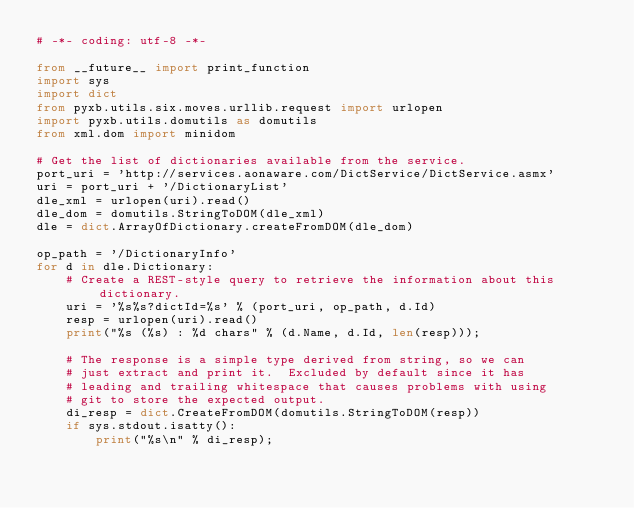<code> <loc_0><loc_0><loc_500><loc_500><_Python_># -*- coding: utf-8 -*-

from __future__ import print_function
import sys
import dict
from pyxb.utils.six.moves.urllib.request import urlopen
import pyxb.utils.domutils as domutils
from xml.dom import minidom

# Get the list of dictionaries available from the service.
port_uri = 'http://services.aonaware.com/DictService/DictService.asmx'
uri = port_uri + '/DictionaryList'
dle_xml = urlopen(uri).read()
dle_dom = domutils.StringToDOM(dle_xml)
dle = dict.ArrayOfDictionary.createFromDOM(dle_dom)

op_path = '/DictionaryInfo'
for d in dle.Dictionary:
    # Create a REST-style query to retrieve the information about this dictionary.
    uri = '%s%s?dictId=%s' % (port_uri, op_path, d.Id)
    resp = urlopen(uri).read()
    print("%s (%s) : %d chars" % (d.Name, d.Id, len(resp)));

    # The response is a simple type derived from string, so we can
    # just extract and print it.  Excluded by default since it has
    # leading and trailing whitespace that causes problems with using
    # git to store the expected output.
    di_resp = dict.CreateFromDOM(domutils.StringToDOM(resp))
    if sys.stdout.isatty():
        print("%s\n" % di_resp);
</code> 